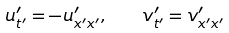Convert formula to latex. <formula><loc_0><loc_0><loc_500><loc_500>u ^ { \prime } _ { t ^ { \prime } } = - u ^ { \prime } _ { x ^ { \prime } x ^ { \prime } } , \quad v ^ { \prime } _ { t ^ { \prime } } = v ^ { \prime } _ { x ^ { \prime } x ^ { \prime } }</formula> 